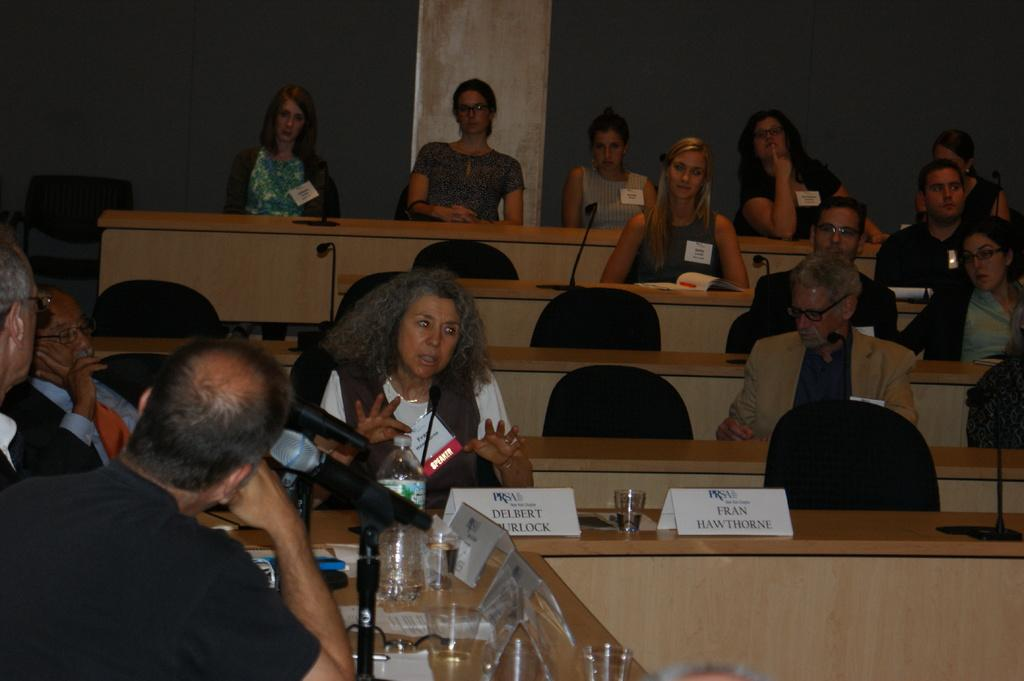What are the persons in the image doing? The persons in the image are sitting on chairs. What furniture is visible in the image besides the chairs? There are tables in the image. What objects can be seen on the tables? There is a name board, glasses, and microphones on a table. What is visible in the background of the image? There is a wall in the background of the image. What type of grass is growing on the tables in the image? There is no grass present on the tables in the image; the objects mentioned are a name board, glasses, and microphones. 